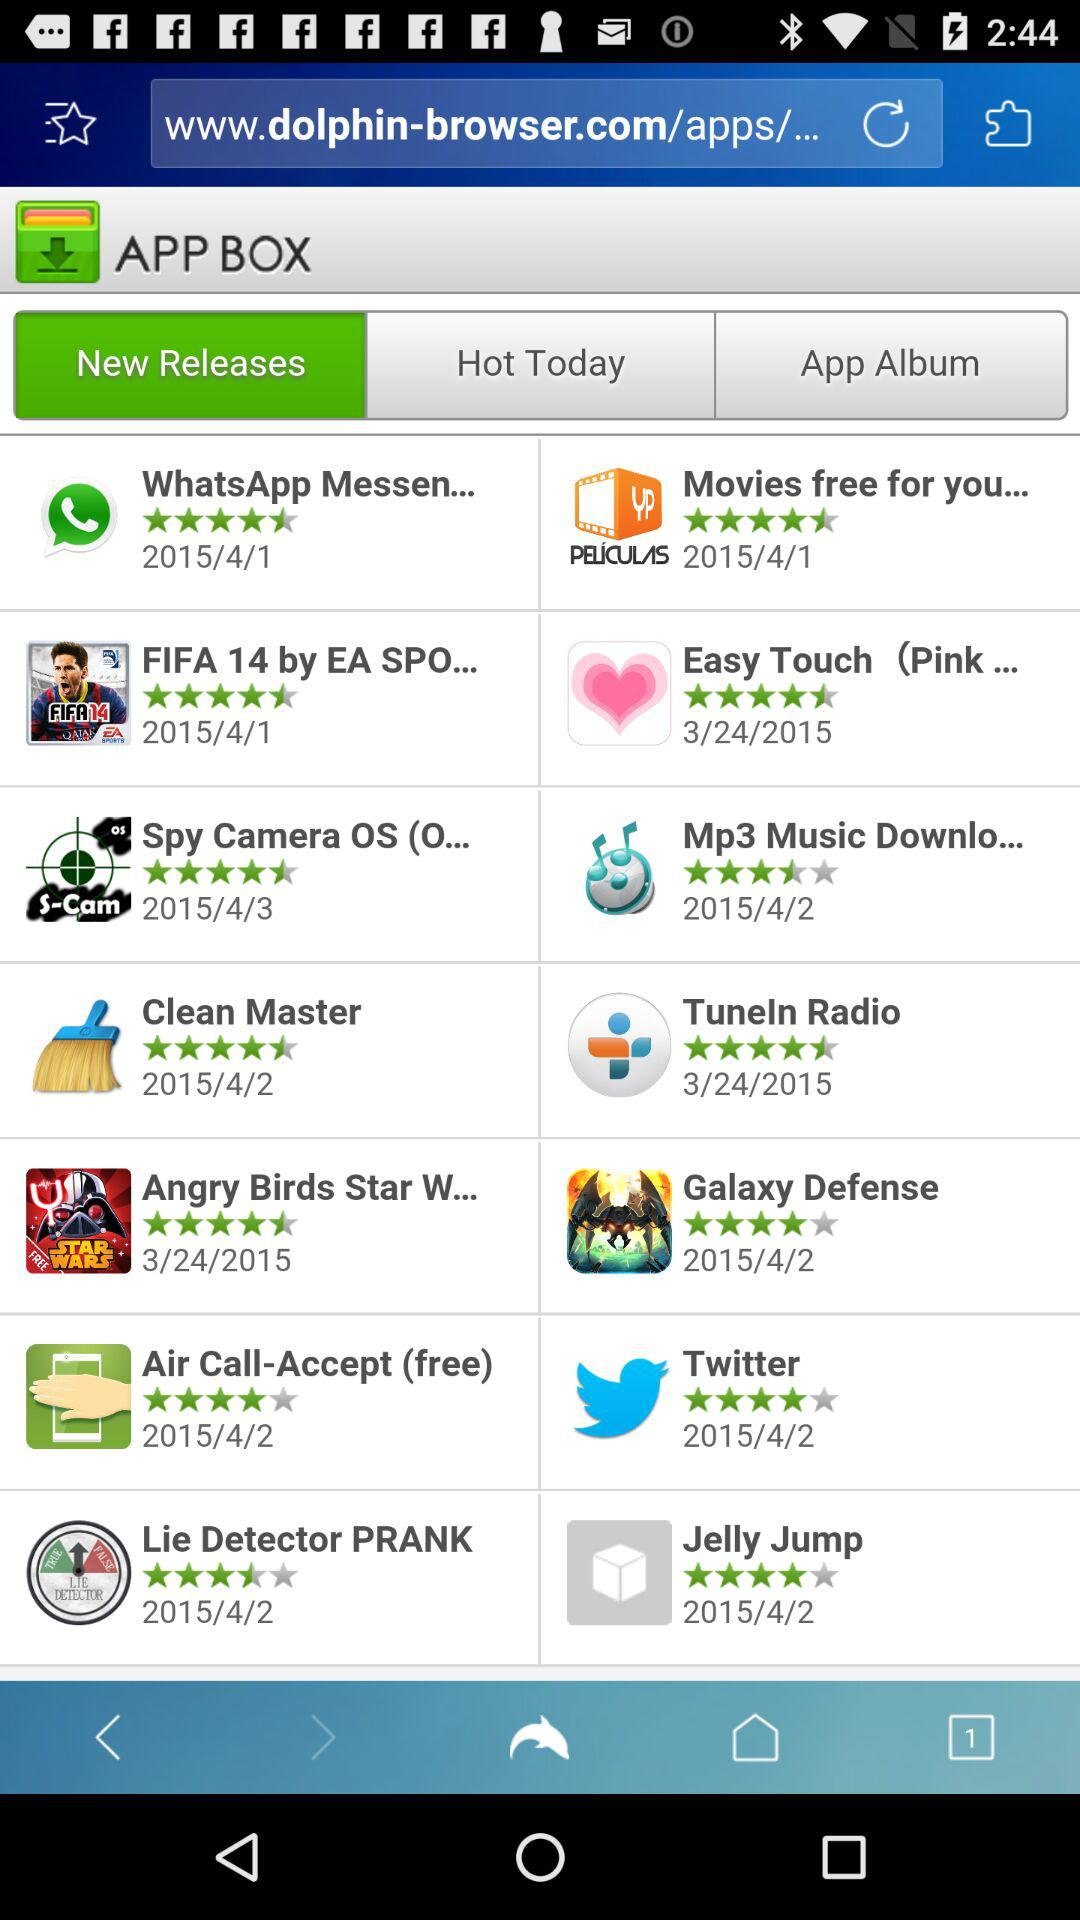What is the release date of the Twitter application? The release date is 2015/4/2. 